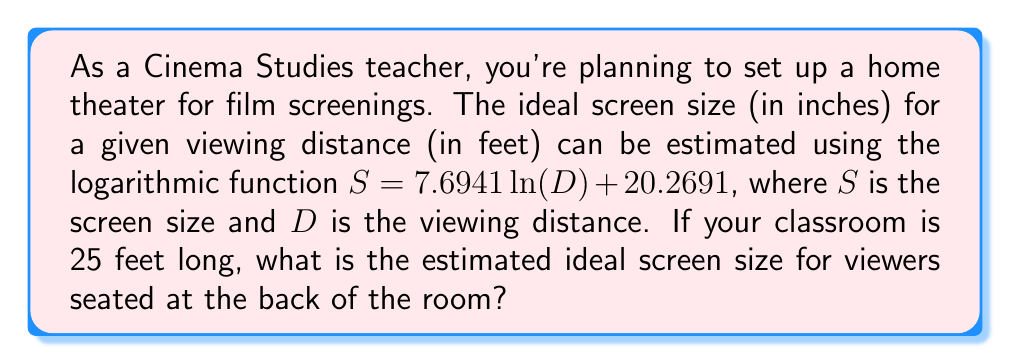Show me your answer to this math problem. To solve this problem, we'll follow these steps:

1. Identify the given information:
   - The function for ideal screen size: $S = 7.6941 \ln(D) + 20.2691$
   - The viewing distance: $D = 25$ feet

2. Substitute the viewing distance into the function:
   $S = 7.6941 \ln(25) + 20.2691$

3. Calculate the natural logarithm of 25:
   $\ln(25) \approx 3.2189$

4. Multiply 7.6941 by the result from step 3:
   $7.6941 \times 3.2189 \approx 24.7670$

5. Add 20.2691 to the result from step 4:
   $24.7670 + 20.2691 \approx 45.0361$

6. Round the result to the nearest inch, as screen sizes are typically given in whole inches:
   $45.0361 \approx 45$ inches

Therefore, the estimated ideal screen size for viewers seated 25 feet away is approximately 45 inches.
Answer: 45 inches 